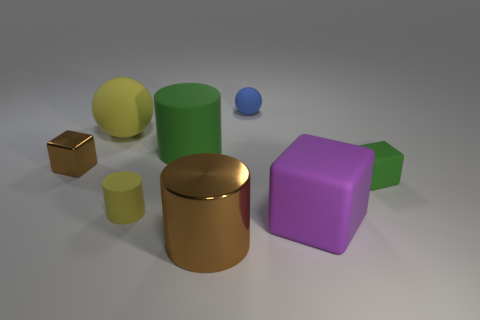Is there any object that stands out in the image? Yes, the gold-colored cylinder stands out due to its reflective surface and distinct color in contrast to the matte textures of the other objects. 